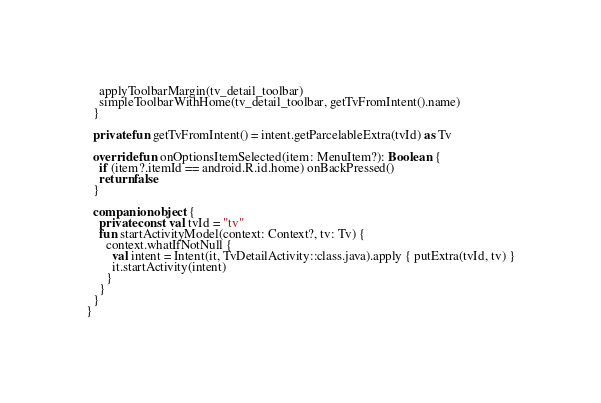<code> <loc_0><loc_0><loc_500><loc_500><_Kotlin_>    applyToolbarMargin(tv_detail_toolbar)
    simpleToolbarWithHome(tv_detail_toolbar, getTvFromIntent().name)
  }

  private fun getTvFromIntent() = intent.getParcelableExtra(tvId) as Tv

  override fun onOptionsItemSelected(item: MenuItem?): Boolean {
    if (item?.itemId == android.R.id.home) onBackPressed()
    return false
  }

  companion object {
    private const val tvId = "tv"
    fun startActivityModel(context: Context?, tv: Tv) {
      context.whatIfNotNull {
        val intent = Intent(it, TvDetailActivity::class.java).apply { putExtra(tvId, tv) }
        it.startActivity(intent)
      }
    }
  }
}
</code> 